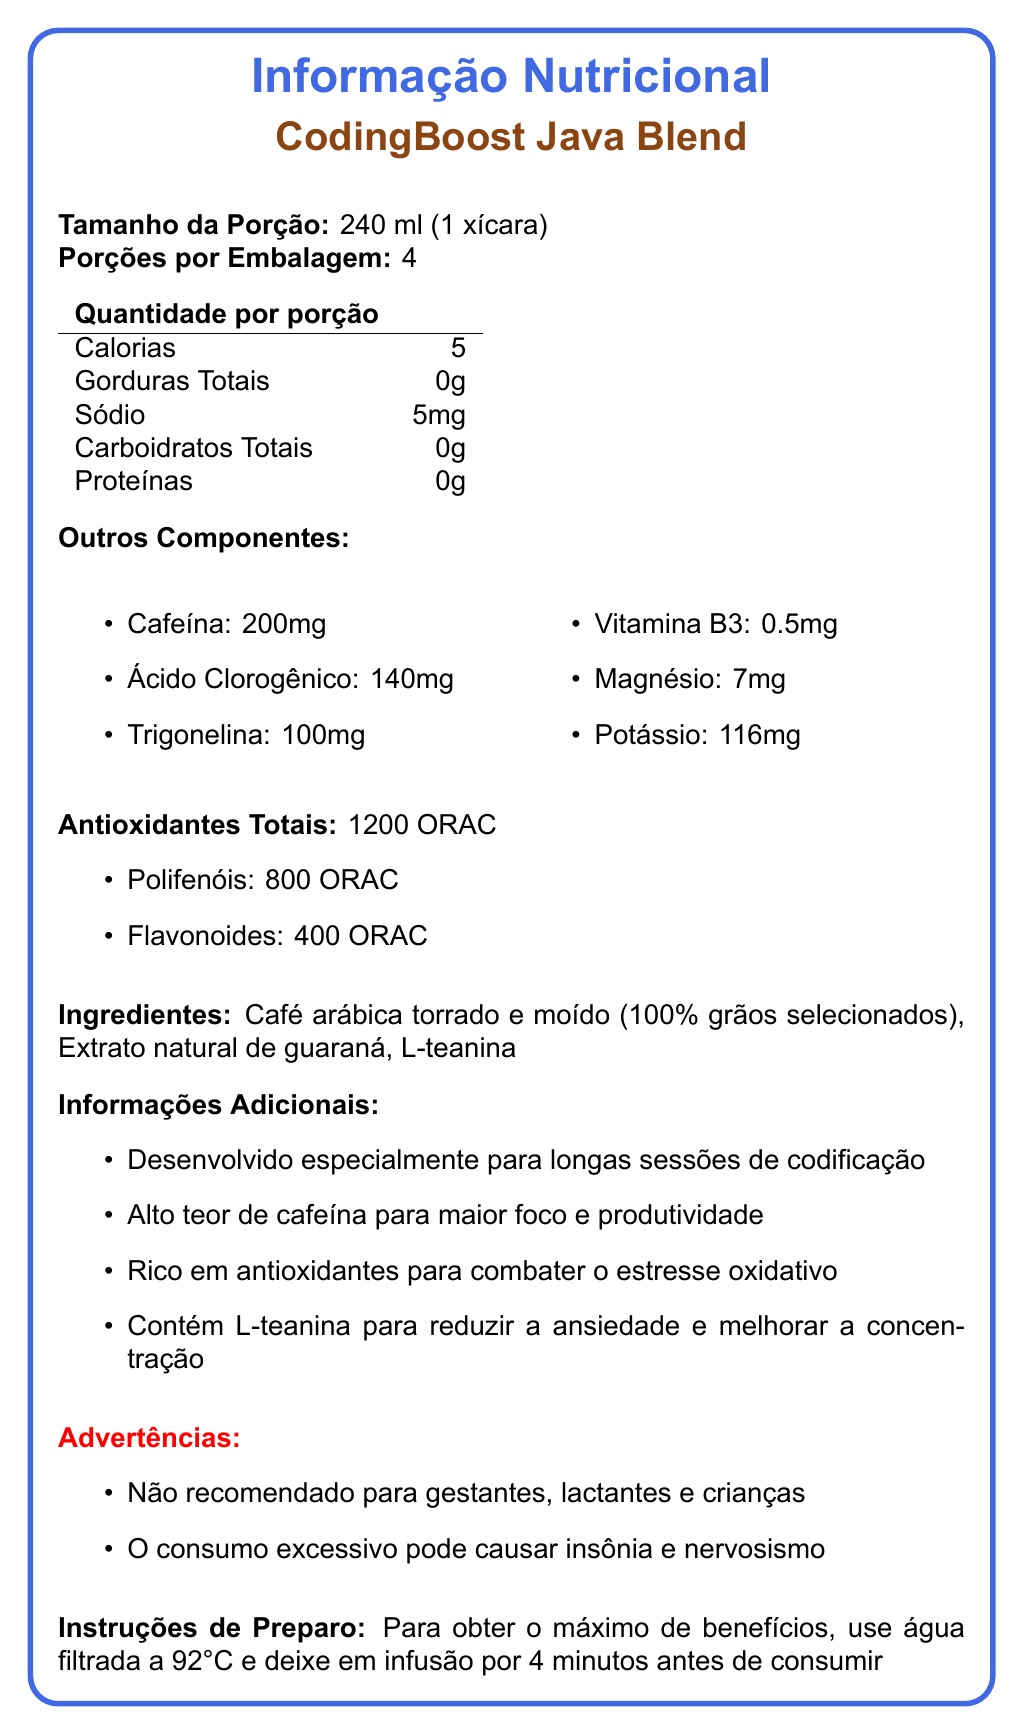what is the product name? The product name is mentioned at the top as "CodingBoost Java Blend".
Answer: CodingBoost Java Blend what is the serving size? The serving size is listed as "240 ml (1 xícara)".
Answer: 240 ml (1 xícara) how many servings are in each container? The document states there are 4 servings per container.
Answer: 4 how much caffeine does each serving contain? The amount of caffeine per serving is listed as "200 mg".
Answer: 200 mg list the antioxidants present in CodingBoost Java Blend. The document lists Polifenóis (800 ORAC) and Flavonoides (400 ORAC) under antioxidants.
Answer: Polifenóis and Flavonoides what warnings are given for this product? Two warnings are given: "Not recommended for gestantes, lactantes e crianças" and "O consumo excessivo pode causar insônia e nervosismo".
Answer: Not recommended for gestantes, lactantes e crianças; O consumo excessivo pode causar insônia e nervosismo how much sodium is in one serving? The document lists the sodium content as 5 mg per serving.
Answer: 5 mg what are the additional benefits mentioned for CodingBoost Java Blend? The additional benefits are: designed specially for long coding sessions, high caffeine for focus and productivity, rich in antioxidants, contains L-theanine to reduce anxiety and improve concentration.
Answer: Designed specially for long coding sessions, high caffeine for focus and productivity, rich in antioxidants, contains L-theanine to reduce anxiety and improve concentration describe the total antioxidant content in terms of ORAC. A. 800 ORAC B. 400 ORAC C. 1200 ORAC D. 600 ORAC The total antioxidant content is 1200 ORAC, comprising 800 ORAC from Polifenóis and 400 ORAC from Flavonoides.
Answer: C. 1200 ORAC which of the following ingredients are listed for CodingBoost Java Blend? A. Sugar B. Café arábica torrado e moído C. Milk D. Artificial Colors Among the given options, only "Café arábica torrado e moído" is listed as an ingredient in the document.
Answer: B. Café arábica torrado e moído should pregnant women consume this coffee? The document specifically states that the product is not recommended for "gestantes" (pregnant women).
Answer: No summarize the entire document. The document comprehensively details the nutritional profile and benefits of CodingBoost Java Blend coffee, highlighting its suitability for long coding sessions due to its high caffeine and antioxidant content, specific ingredients, warnings, and proper brewing instructions.
Answer: The document provides the nutritional information of CodingBoost Java Blend coffee, highlighting its benefits for long coding sessions. It includes details on serving size, calorie count, caffeine, chlorogenic acid, trigonelline, antioxidants (Polifenóis and Flavonoides), and vitamins and minerals content. The ingredients are mainly roasted and ground arabica coffee, guaraná extract, and L-theanine. The document also emphasizes its high antioxidant and caffeine content for focus and productivity, mentions warnings for certain groups, and provides brewing instructions for optimal benefits. how much protein is in one serving of this coffee? The protein content per serving is listed as 0 g in the nutritional information section.
Answer: 0 g what are the brewing instructions for CodingBoost Java Blend? The brewing instructions specify using filtered water at 92°C and steeping for 4 minutes for maximum benefits.
Answer: Use filtered water at 92°C and steep for 4 minutes before consuming how many calories are there in a single serving? The calorie content per serving is listed as 5 calories.
Answer: 5 calories what is the sodium content in the entire container if it holds 4 servings? Since each serving contains 5 mg of sodium, 4 servings would contain 5 mg x 4 = 20 mg of sodium.
Answer: 20 mg what does the document suggest about the antioxidant content in terms of ORAC units? The document provides a breakdown of antioxidant content in ORAC units, with a total of 1200 ORAC, of which 800 is from Polifenóis and 400 from Flavonoides.
Answer: The total antioxidant content is 1200 ORAC, including 800 ORAC from Polifenóis and 400 ORAC from Flavonoides who should avoid consuming this coffee according to the document? The warnings section specifies that pregnant women, lactating women, and children should avoid consuming this product.
Answer: Pregnant women, lactating women, and children should avoid consuming this coffee what is the exact amount of trigonelline in one serving? The document lists the trigonelline content per serving as 100 mg.
Answer: 100 mg what type of coffee is used in the CodingBoost Java Blend? The ingredients section specifies that the coffee used is "Café arábica torrado e moído."
Answer: Roasted and ground arabica coffee explain why you might choose CodingBoost Java Blend for a long coding session. The document highlights the high caffeine content, antioxidants, and added L-theanine that collectively help in maintaining focus, productivity, reducing anxiety, and combating oxidative stress during long coding sessions.
Answer: CodingBoost Java Blend is specially designed for long coding sessions with high caffeine content for focus and productivity, rich antioxidants to combat oxidative stress, and L-theanine to reduce anxiety and improve concentration. The document emphasizes these benefits, making it an appealing choice for maintaining high energy levels and mental clarity during extended periods of coding. what is the total amount of potassium in the entire container if it contains 4 servings? Each serving contains 116 mg of potassium, so 4 servings would contain 116 mg x 4 = 464 mg of potassium.
Answer: 464 mg can the exact origin or supplier of the coffee beans be determined from the document? The document does not provide any specific information about the origin or supplier of the coffee beans beyond mentioning "100% grãos selecionados (selected beans)."
Answer: Cannot be determined 